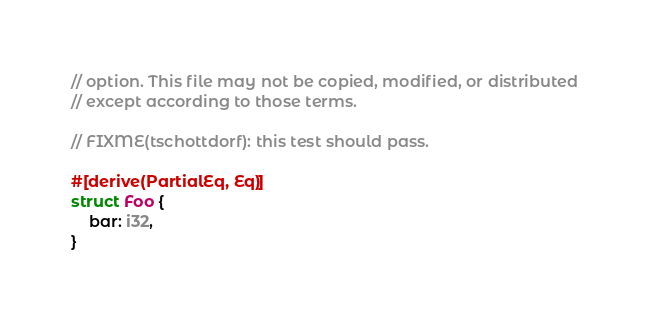Convert code to text. <code><loc_0><loc_0><loc_500><loc_500><_Rust_>// option. This file may not be copied, modified, or distributed
// except according to those terms.

// FIXME(tschottdorf): this test should pass.

#[derive(PartialEq, Eq)]
struct Foo {
    bar: i32,
}
</code> 